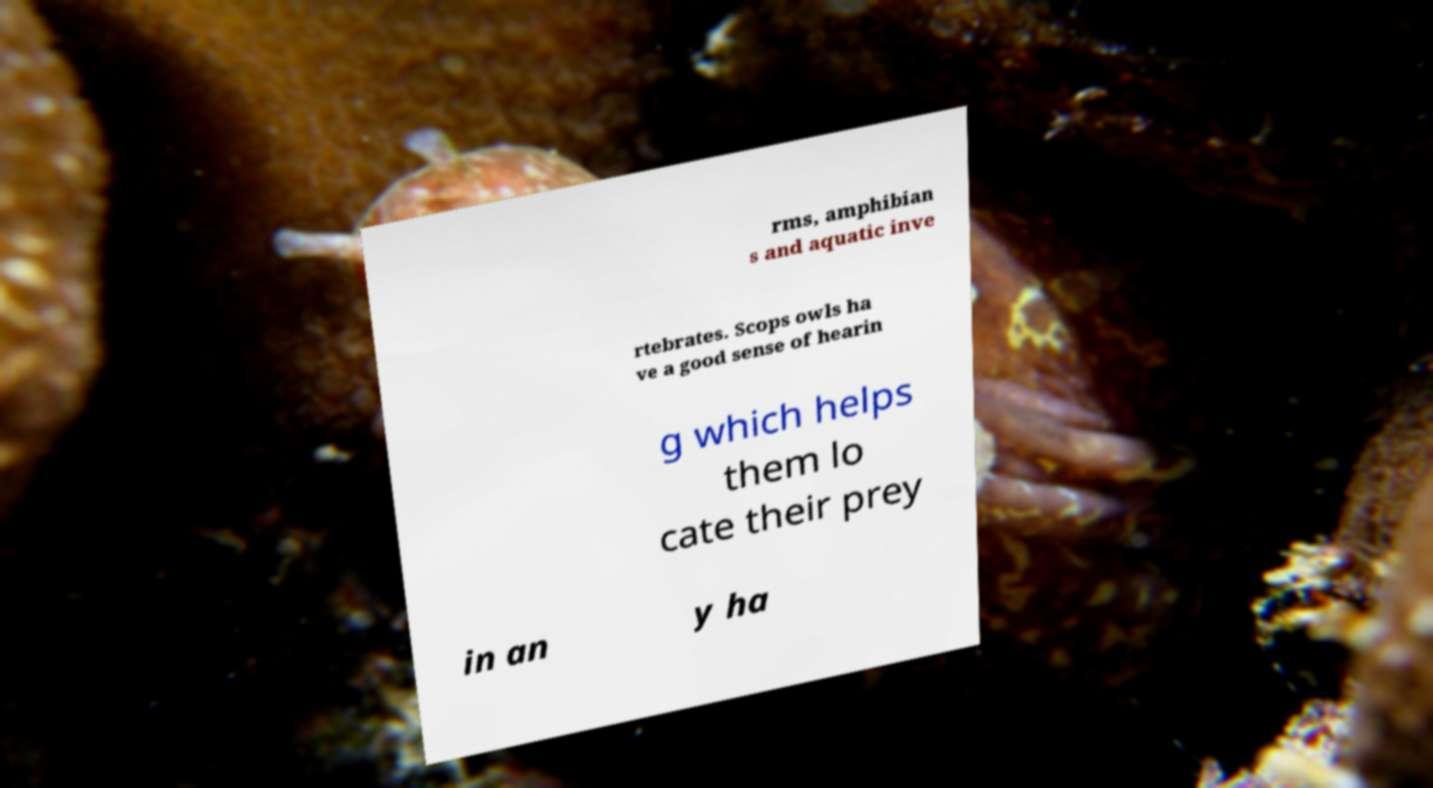Can you accurately transcribe the text from the provided image for me? rms, amphibian s and aquatic inve rtebrates. Scops owls ha ve a good sense of hearin g which helps them lo cate their prey in an y ha 